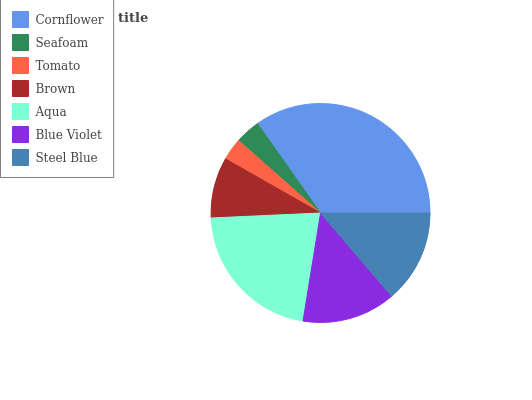Is Tomato the minimum?
Answer yes or no. Yes. Is Cornflower the maximum?
Answer yes or no. Yes. Is Seafoam the minimum?
Answer yes or no. No. Is Seafoam the maximum?
Answer yes or no. No. Is Cornflower greater than Seafoam?
Answer yes or no. Yes. Is Seafoam less than Cornflower?
Answer yes or no. Yes. Is Seafoam greater than Cornflower?
Answer yes or no. No. Is Cornflower less than Seafoam?
Answer yes or no. No. Is Steel Blue the high median?
Answer yes or no. Yes. Is Steel Blue the low median?
Answer yes or no. Yes. Is Brown the high median?
Answer yes or no. No. Is Seafoam the low median?
Answer yes or no. No. 